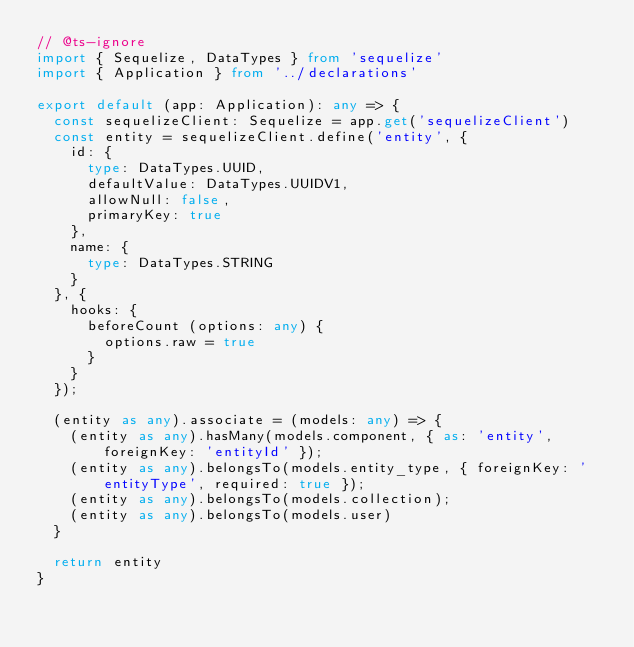<code> <loc_0><loc_0><loc_500><loc_500><_TypeScript_>// @ts-ignore
import { Sequelize, DataTypes } from 'sequelize'
import { Application } from '../declarations'

export default (app: Application): any => {
  const sequelizeClient: Sequelize = app.get('sequelizeClient')
  const entity = sequelizeClient.define('entity', {
    id: {
      type: DataTypes.UUID,
      defaultValue: DataTypes.UUIDV1,
      allowNull: false,
      primaryKey: true
    },
    name: {
      type: DataTypes.STRING
    }
  }, {
    hooks: {
      beforeCount (options: any) {
        options.raw = true
      }
    }
  });

  (entity as any).associate = (models: any) => {
    (entity as any).hasMany(models.component, { as: 'entity', foreignKey: 'entityId' });
    (entity as any).belongsTo(models.entity_type, { foreignKey: 'entityType', required: true });
    (entity as any).belongsTo(models.collection);
    (entity as any).belongsTo(models.user)
  }

  return entity
}
</code> 